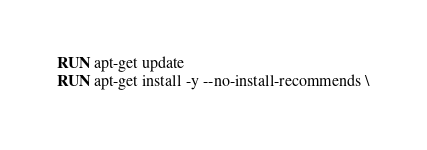<code> <loc_0><loc_0><loc_500><loc_500><_Dockerfile_>RUN apt-get update
RUN apt-get install -y --no-install-recommends \</code> 